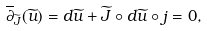<formula> <loc_0><loc_0><loc_500><loc_500>\overline { \partial } _ { \widetilde { J } } ( \widetilde { u } ) = d \widetilde { u } + \widetilde { J } \circ d \widetilde { u } \circ j = 0 ,</formula> 